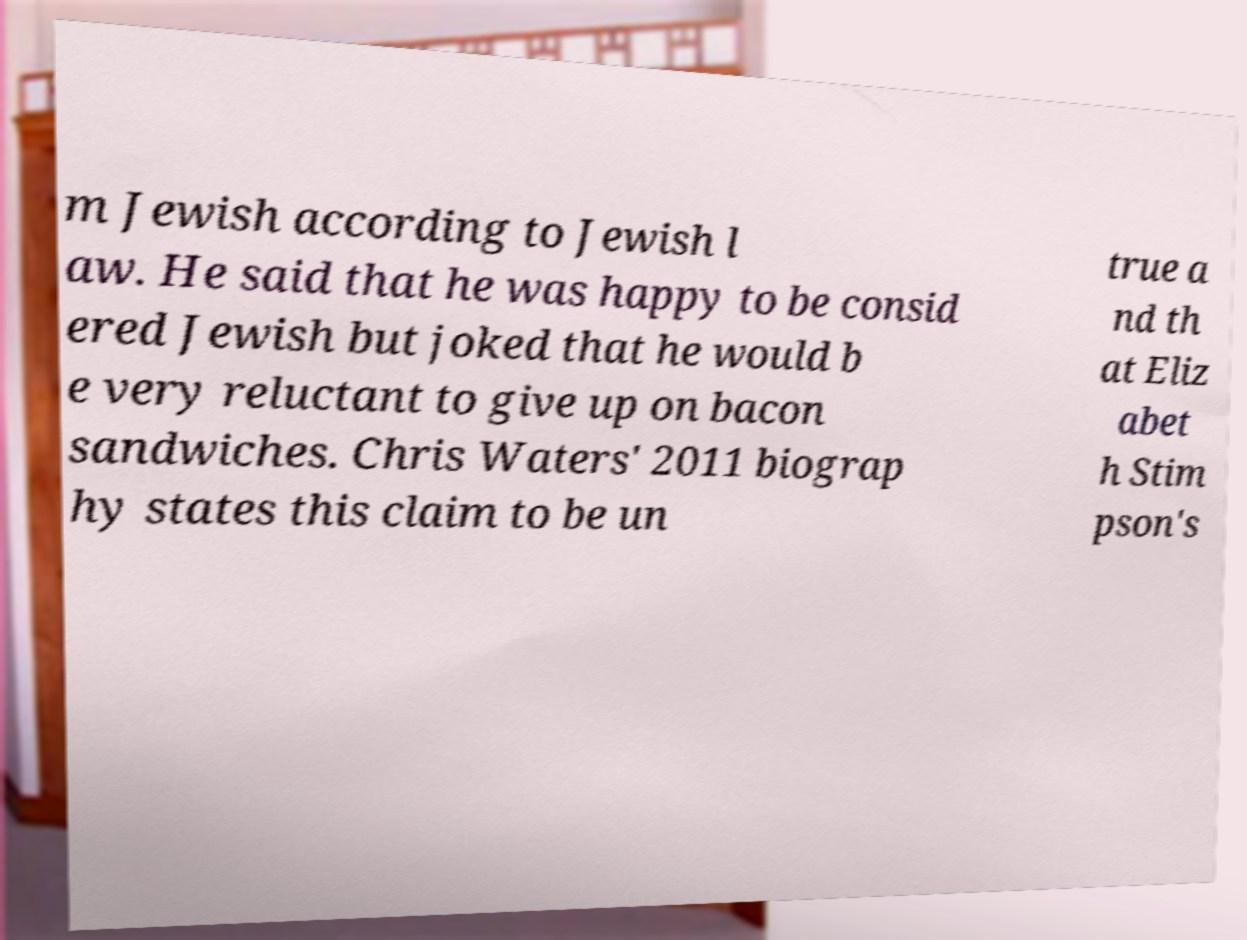Please read and relay the text visible in this image. What does it say? m Jewish according to Jewish l aw. He said that he was happy to be consid ered Jewish but joked that he would b e very reluctant to give up on bacon sandwiches. Chris Waters' 2011 biograp hy states this claim to be un true a nd th at Eliz abet h Stim pson's 